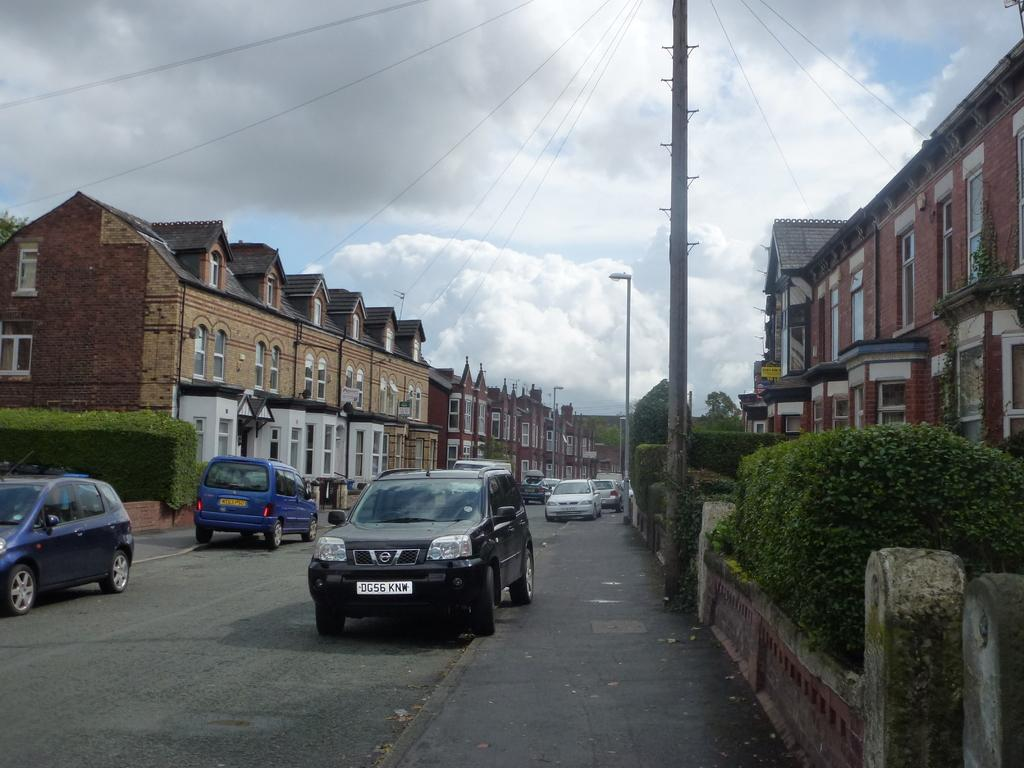What can be seen on the road in the image? There are cars on the road in the image. What structures are located on either side of the road? There are buildings on either side of the road in the image. What type of vegetation is in front of the buildings? There are trees in front of the buildings in the image. What is visible above the buildings and cars? The sky is visible in the image, and clouds are present in the sky. What type of form can be seen on the wrist of the person in the image? There is no person present in the image, and therefore no wrist or form can be observed. What mountain range can be seen in the background of the image? There is no mountain range present in the image; it features buildings, trees, and cars on a road. 